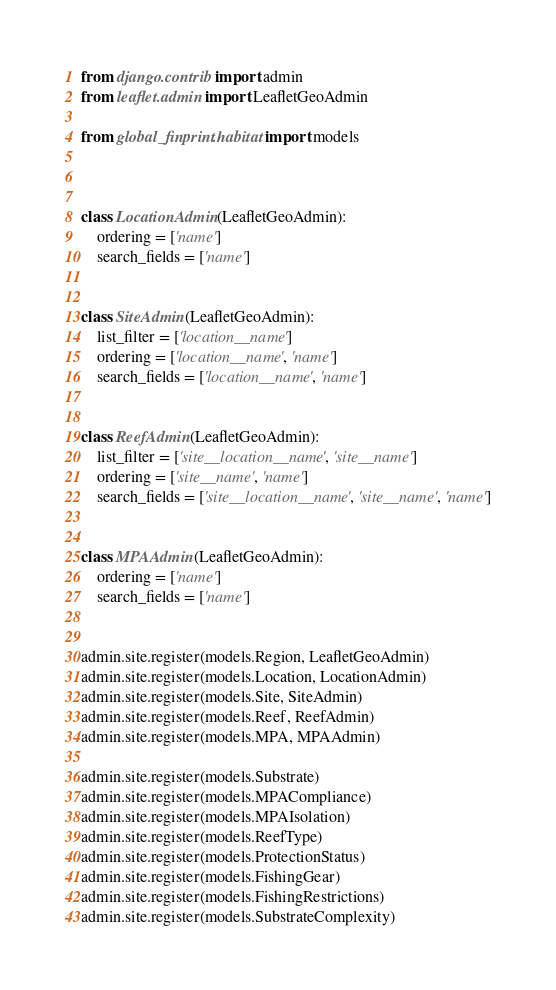Convert code to text. <code><loc_0><loc_0><loc_500><loc_500><_Python_>from django.contrib import admin
from leaflet.admin import LeafletGeoAdmin

from global_finprint.habitat import models



class LocationAdmin(LeafletGeoAdmin):
    ordering = ['name']
    search_fields = ['name']


class SiteAdmin(LeafletGeoAdmin):
    list_filter = ['location__name']
    ordering = ['location__name', 'name']
    search_fields = ['location__name', 'name']


class ReefAdmin(LeafletGeoAdmin):
    list_filter = ['site__location__name', 'site__name']
    ordering = ['site__name', 'name']
    search_fields = ['site__location__name', 'site__name', 'name']


class MPAAdmin(LeafletGeoAdmin):
    ordering = ['name']
    search_fields = ['name']


admin.site.register(models.Region, LeafletGeoAdmin)
admin.site.register(models.Location, LocationAdmin)
admin.site.register(models.Site, SiteAdmin)
admin.site.register(models.Reef, ReefAdmin)
admin.site.register(models.MPA, MPAAdmin)

admin.site.register(models.Substrate)
admin.site.register(models.MPACompliance)
admin.site.register(models.MPAIsolation)
admin.site.register(models.ReefType)
admin.site.register(models.ProtectionStatus)
admin.site.register(models.FishingGear)
admin.site.register(models.FishingRestrictions)
admin.site.register(models.SubstrateComplexity)
</code> 